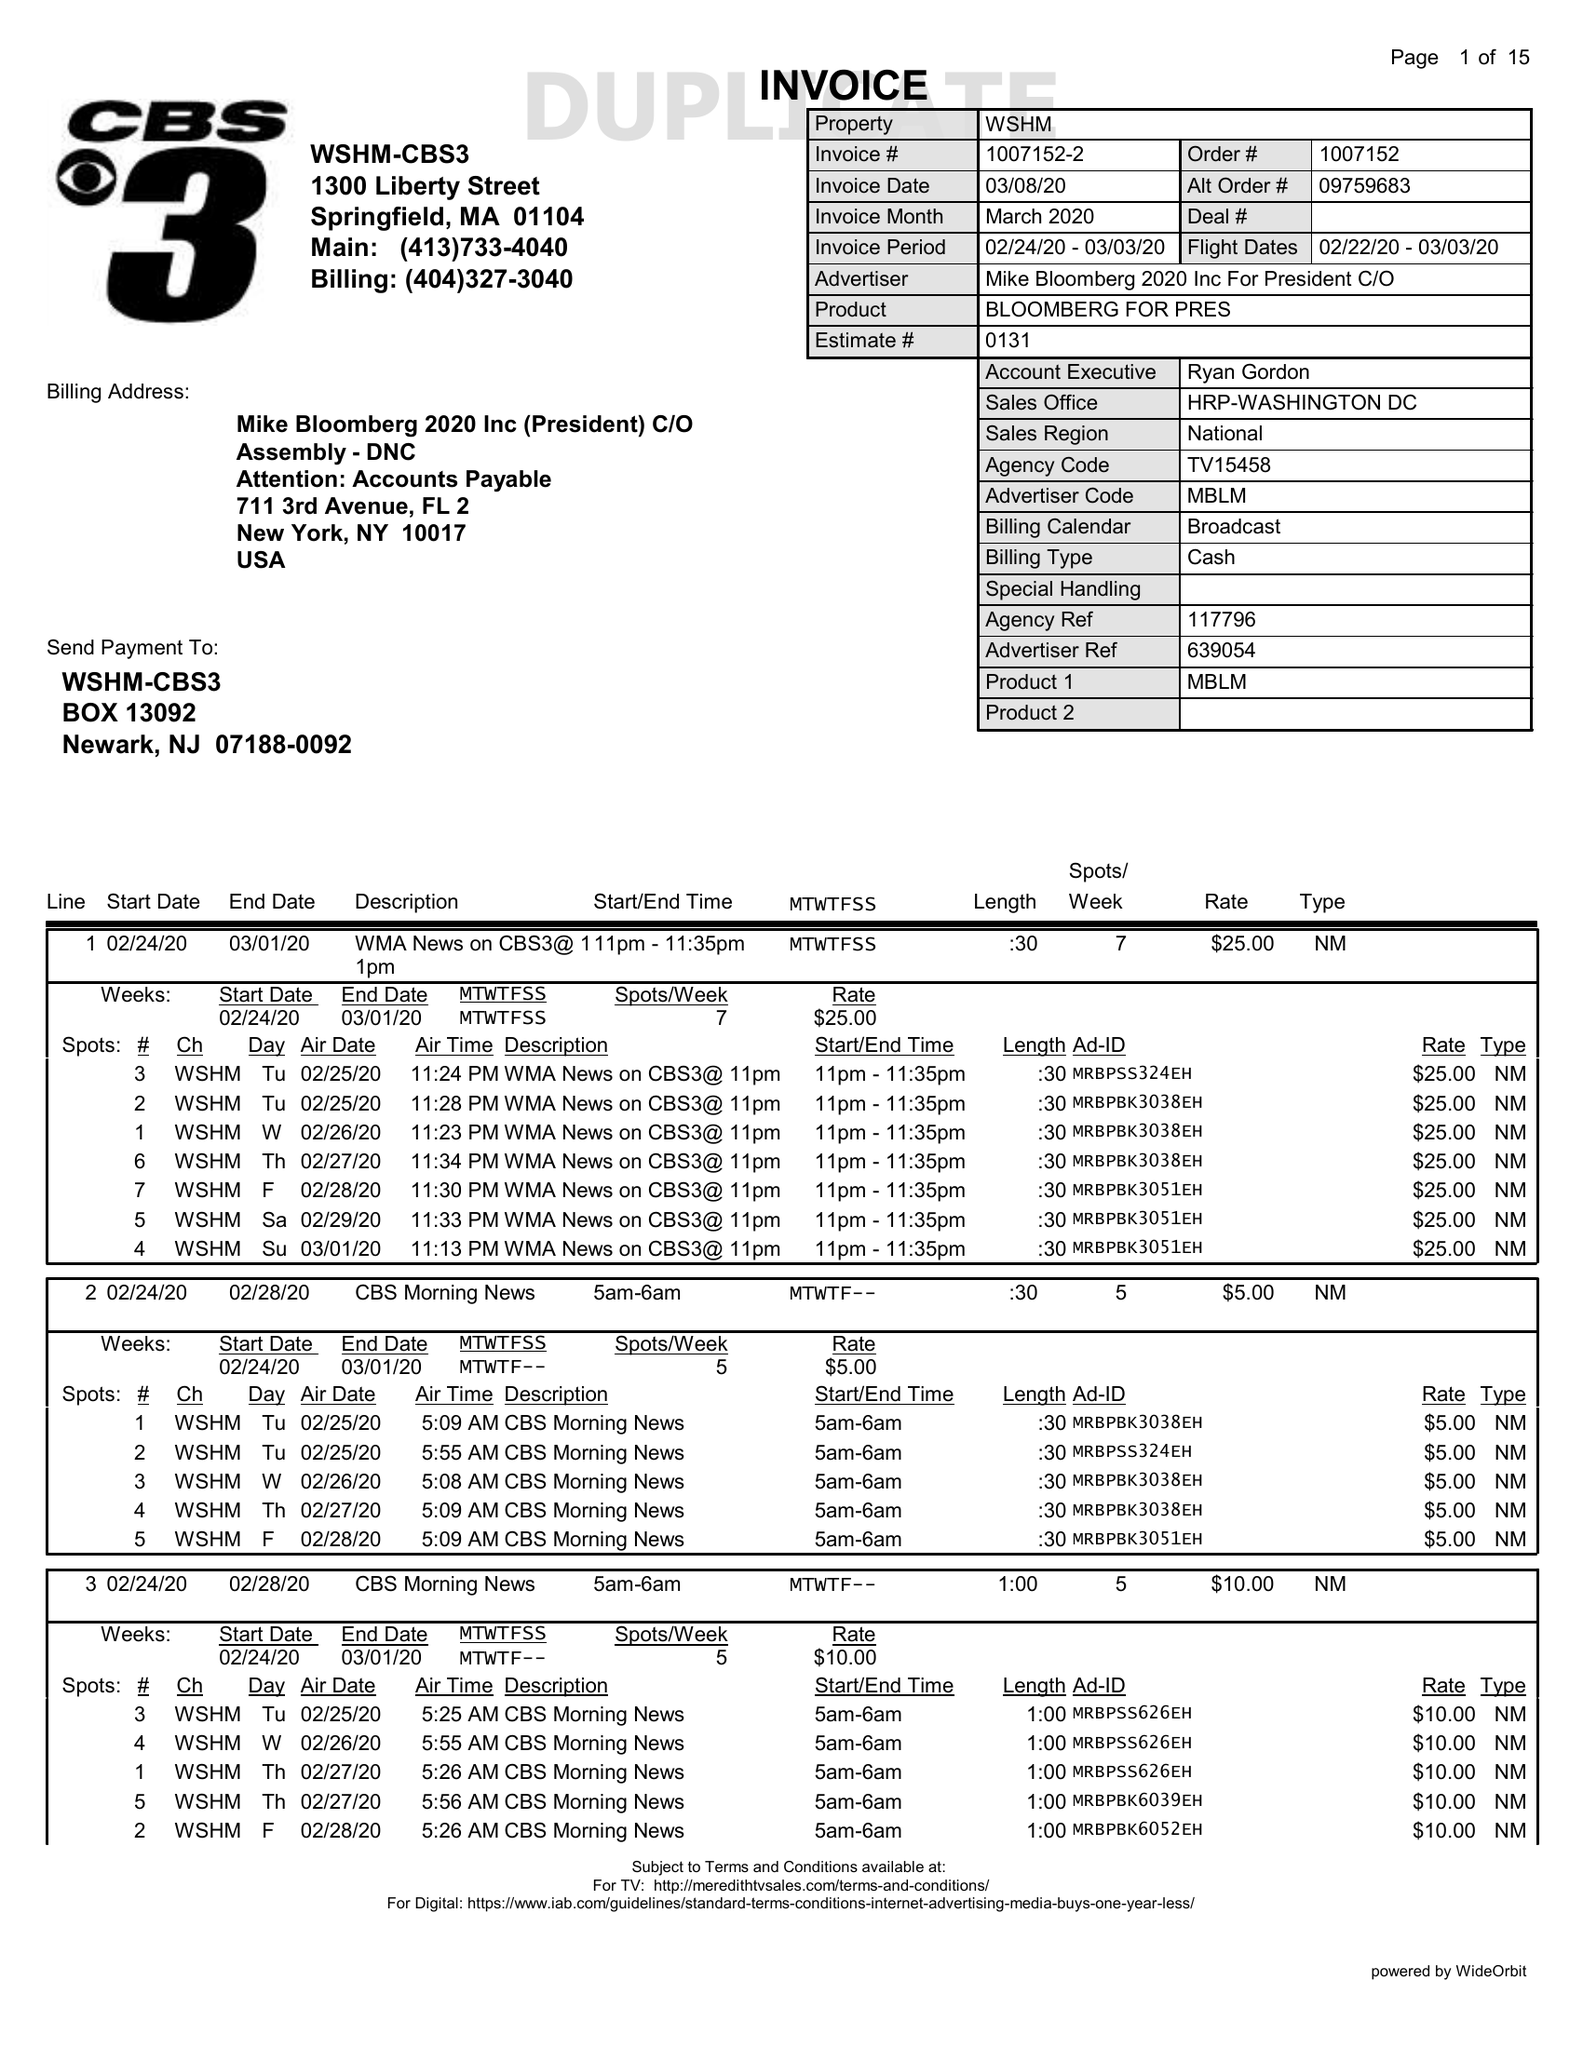What is the value for the contract_num?
Answer the question using a single word or phrase. 1007152 